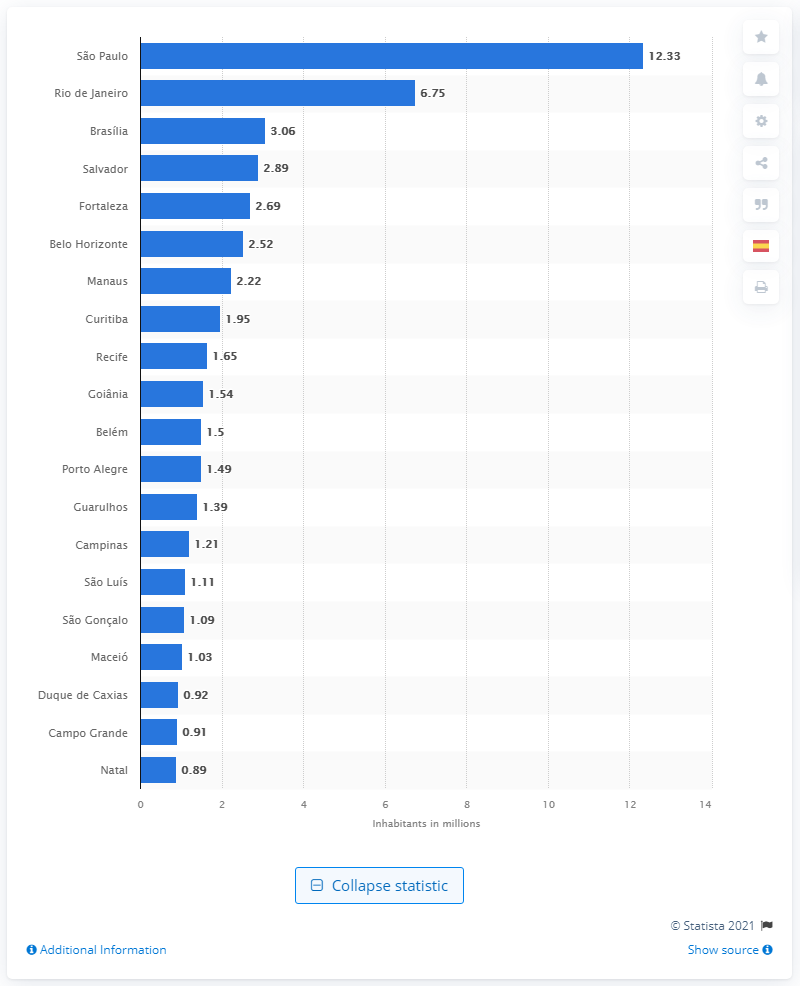Give some essential details in this illustration. As of July 1st of 2020, the estimated number of people living in S£o Paulo was 12,330,000. 